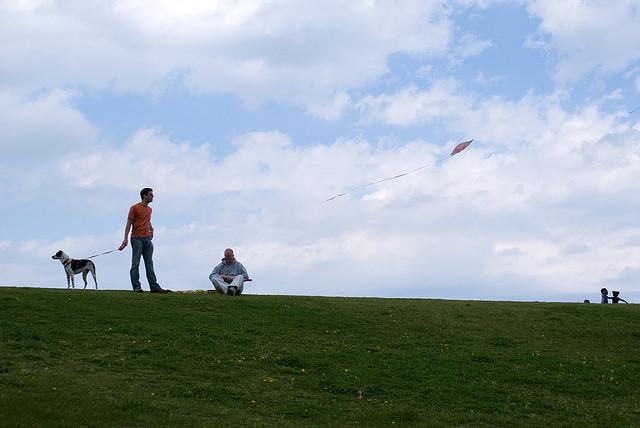Is the man performing an act?
Answer briefly. No. What is the white object behind the two people?
Concise answer only. Clouds. How many dogs are in the picture?
Answer briefly. 1. Is the dog on a leash?
Give a very brief answer. Yes. What is the man sitting on?
Answer briefly. Grass. Are there tables?
Short answer required. No. Where is the child located in the picture?
Give a very brief answer. Right. Is it a clear day?
Answer briefly. Yes. Are there children in the background?
Give a very brief answer. Yes. 